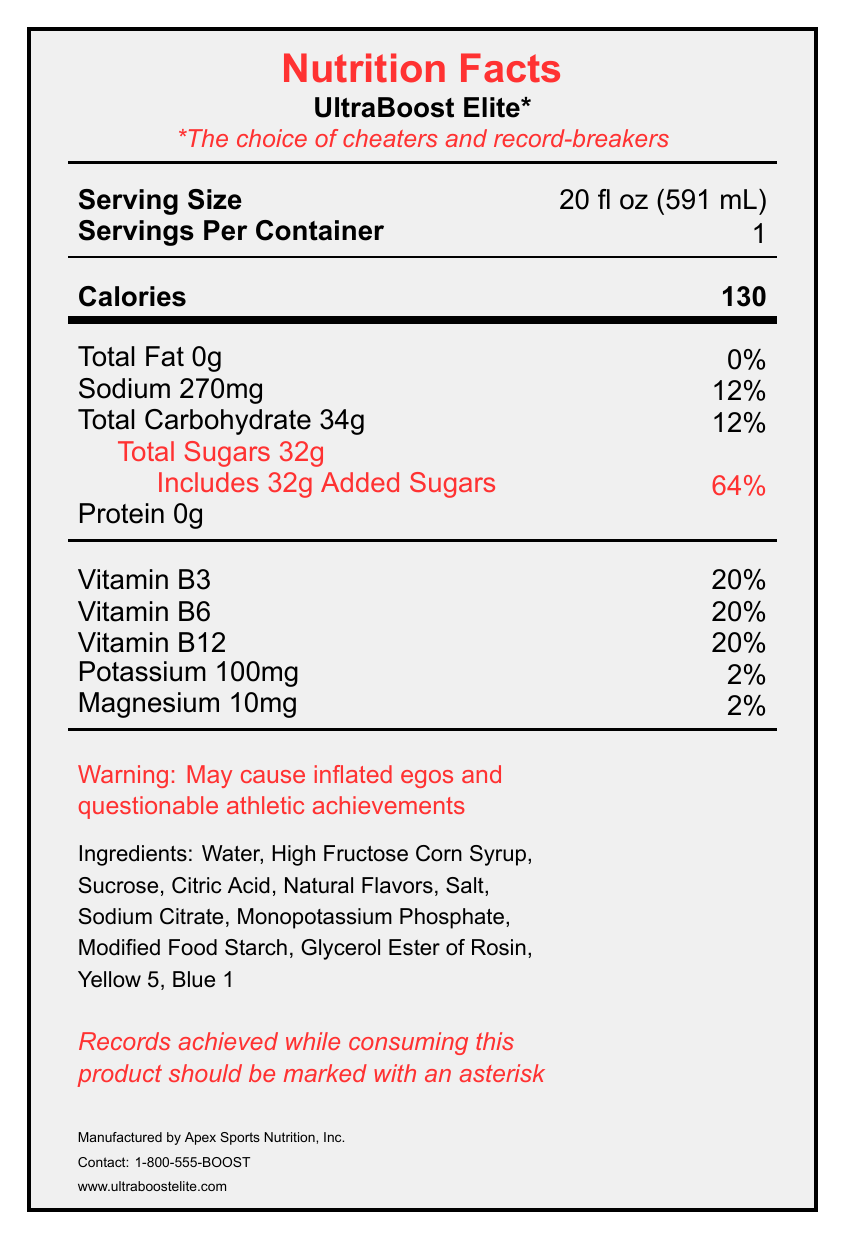what is the serving size for UltraBoost Elite? The serving size is listed as "20 fl oz (591 mL)" in the document.
Answer: 20 fl oz (591 mL) how many grams of total sugars are in a serving? The nutrition label states that "Total Sugars" is 32g.
Answer: 32g what percentage of the daily value of sodium does a serving contain? The document shows "Sodium 270mg" which includes the percentage: "12%."
Answer: 12% what is the main warning message printed on the label? The warning message is explicitly stated as "Warning: May cause inflated egos and questionable athletic achievements."
Answer: May cause inflated egos and questionable athletic achievements who is the manufacturer of UltraBoost Elite? The manufacturer's name is listed at the bottom of the document.
Answer: Apex Sports Nutrition, Inc. which color additives are listed in the ingredients? The ingredients section lists "Yellow 5" and "Blue 1" as color additives.
Answer: Yellow 5, Blue 1 what is the main performance claim made by the UltraBoost Elite? A. Boosts endurance by 200% B. Increases reaction time by 50% C. Enhances muscle recovery in half the time D. All of the above All the listed claims are performance claims as stated under the "performance_claims" section of the document.
Answer: D how many grams of protein does UltraBoost Elite contain? The nutrition label shows that it has "Protein 0g."
Answer: 0g what is the daily value percentage of vitamin B12 in the drink? A. 10% B. 15% C. 20% D. 25% The daily value percentage of vitamin B12 is listed as "20%."
Answer: C is the percentage of added sugars high for a single serving? The document shows "64%" for added sugars, which is a high percentage for a single serving.
Answer: Yes summarize the entire document. This summary captures the main sections and highlights of the document including the performance claims, nutrient content, and warnings.
Answer: The document provides the Nutrition Facts for UltraBoost Elite, a sports drink with several performance claims. The label details the serving size, calorie content, macro and micronutrients, and includes a warning about the potential for inflated egos and questionable achievements. The document also displays the ingredients and the manufacturer's contact info. what is the contact number for Apex Sports Nutrition, Inc.? The contact number provided is "1-800-555-BOOST."
Answer: 1-800-555-BOOST how much potassium does UltraBoost Elite contain per serving? The amount of potassium per serving is listed as "100mg."
Answer: 100mg how many servings are there in one container of UltraBoost Elite? The label states "Servings Per Container: 1."
Answer: 1 who should evaluate the performance claims according to the label? The performance claims have a disclaimer noting they have not been evaluated by the FDA, but the document does not specify who should evaluate them.
Answer: Not enough information 